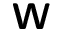<formula> <loc_0><loc_0><loc_500><loc_500>W</formula> 